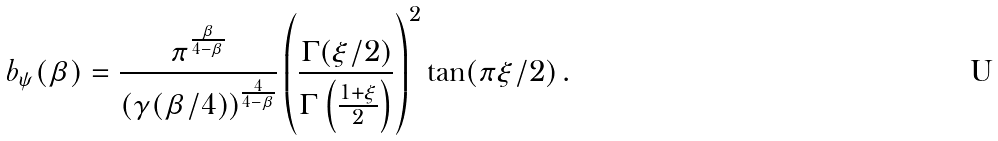Convert formula to latex. <formula><loc_0><loc_0><loc_500><loc_500>b _ { \psi } ( \beta ) = \frac { \pi ^ { \frac { \beta } { 4 - \beta } } } { ( \gamma ( \beta / 4 ) ) ^ { \frac { 4 } { 4 - \beta } } } \left ( \frac { \Gamma ( \xi / 2 ) } { \Gamma \left ( \frac { 1 + \xi } { 2 } \right ) } \right ) ^ { 2 } \tan ( \pi \xi / 2 ) \, .</formula> 